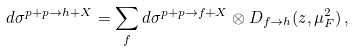Convert formula to latex. <formula><loc_0><loc_0><loc_500><loc_500>d \sigma ^ { p + p \to h + X } = \sum _ { f } d \sigma ^ { p + p \to f + X } \otimes D _ { f \to h } ( z , \mu ^ { 2 } _ { F } ) \, ,</formula> 